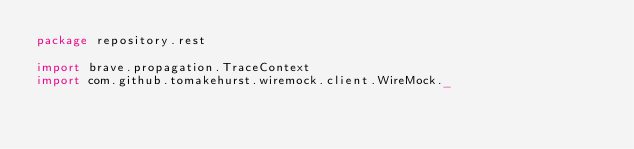<code> <loc_0><loc_0><loc_500><loc_500><_Scala_>package repository.rest

import brave.propagation.TraceContext
import com.github.tomakehurst.wiremock.client.WireMock._</code> 